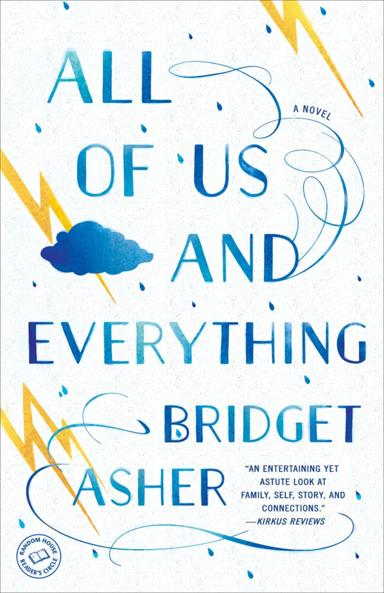What are the main themes of the novel mentioned in the image? The novel "All of Us and Everything" focuses on themes such as family, self, story, and connections. It delves into how familial bonds shape personal identity and the stories we tell about ourselves, sparking reflection on the connections that bind us together. 